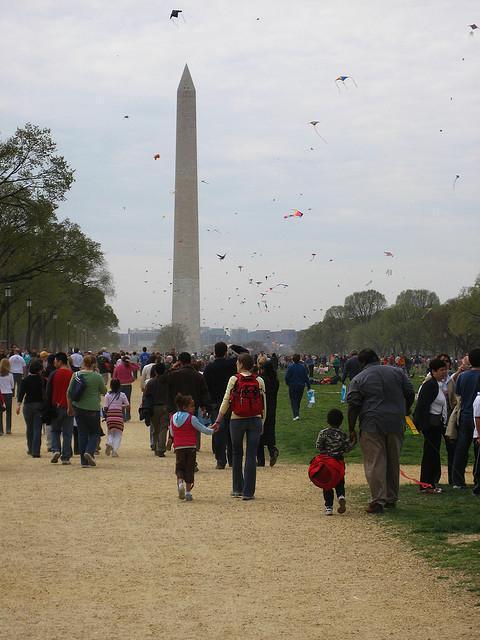How many people are there?
Give a very brief answer. 8. How many of the benches on the boat have chains attached to them?
Give a very brief answer. 0. 